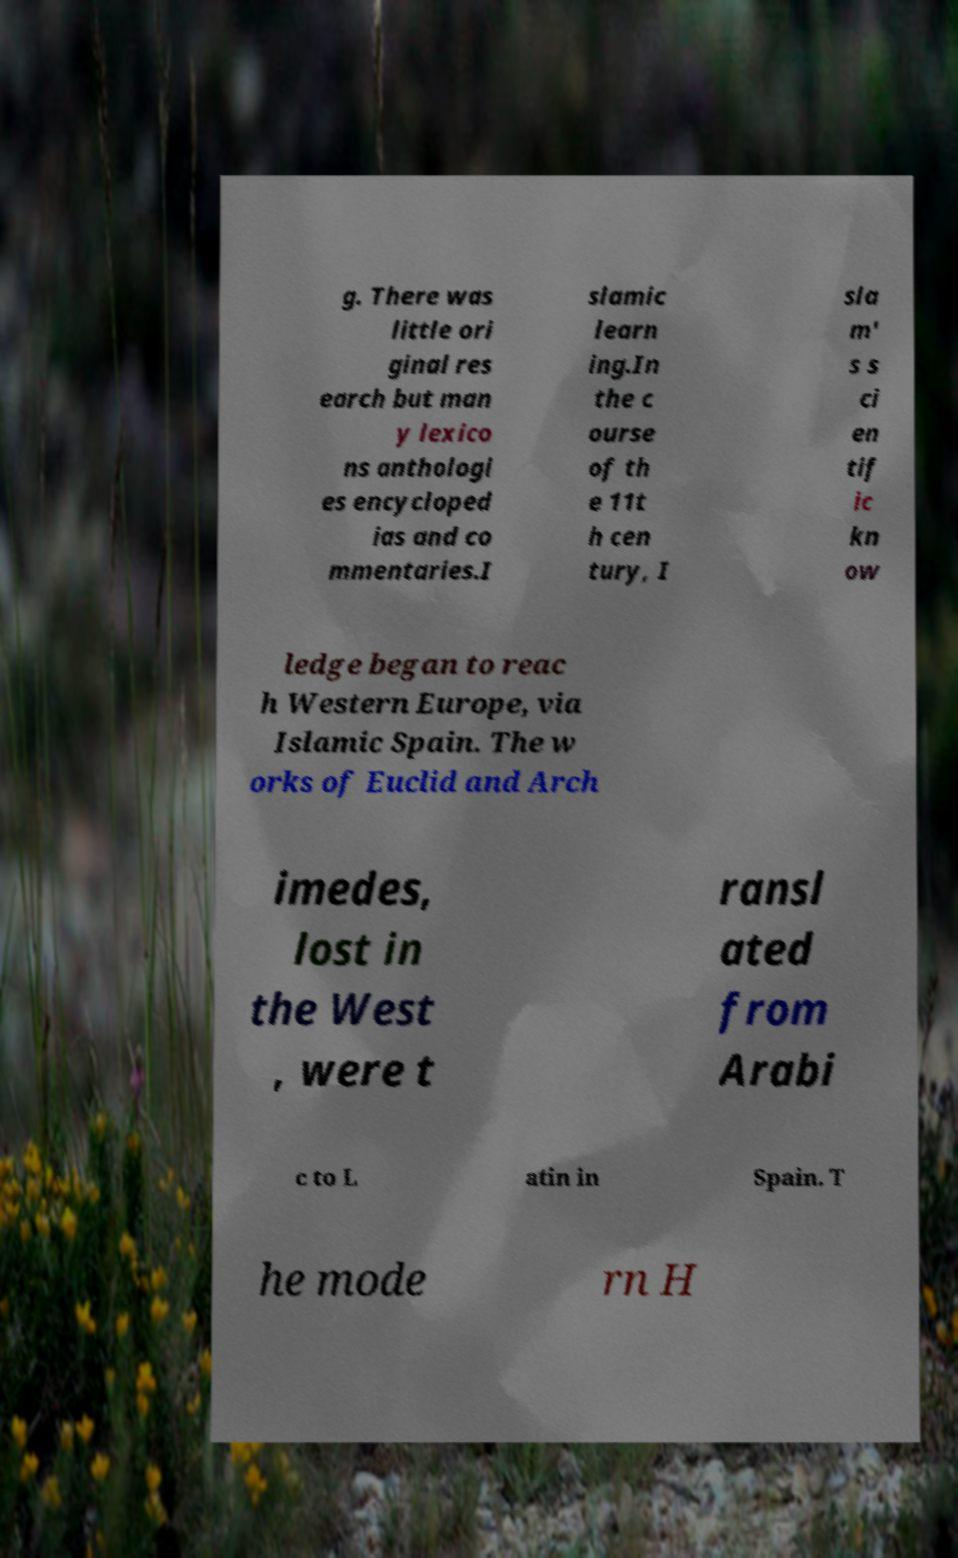What messages or text are displayed in this image? I need them in a readable, typed format. g. There was little ori ginal res earch but man y lexico ns anthologi es encycloped ias and co mmentaries.I slamic learn ing.In the c ourse of th e 11t h cen tury, I sla m' s s ci en tif ic kn ow ledge began to reac h Western Europe, via Islamic Spain. The w orks of Euclid and Arch imedes, lost in the West , were t ransl ated from Arabi c to L atin in Spain. T he mode rn H 